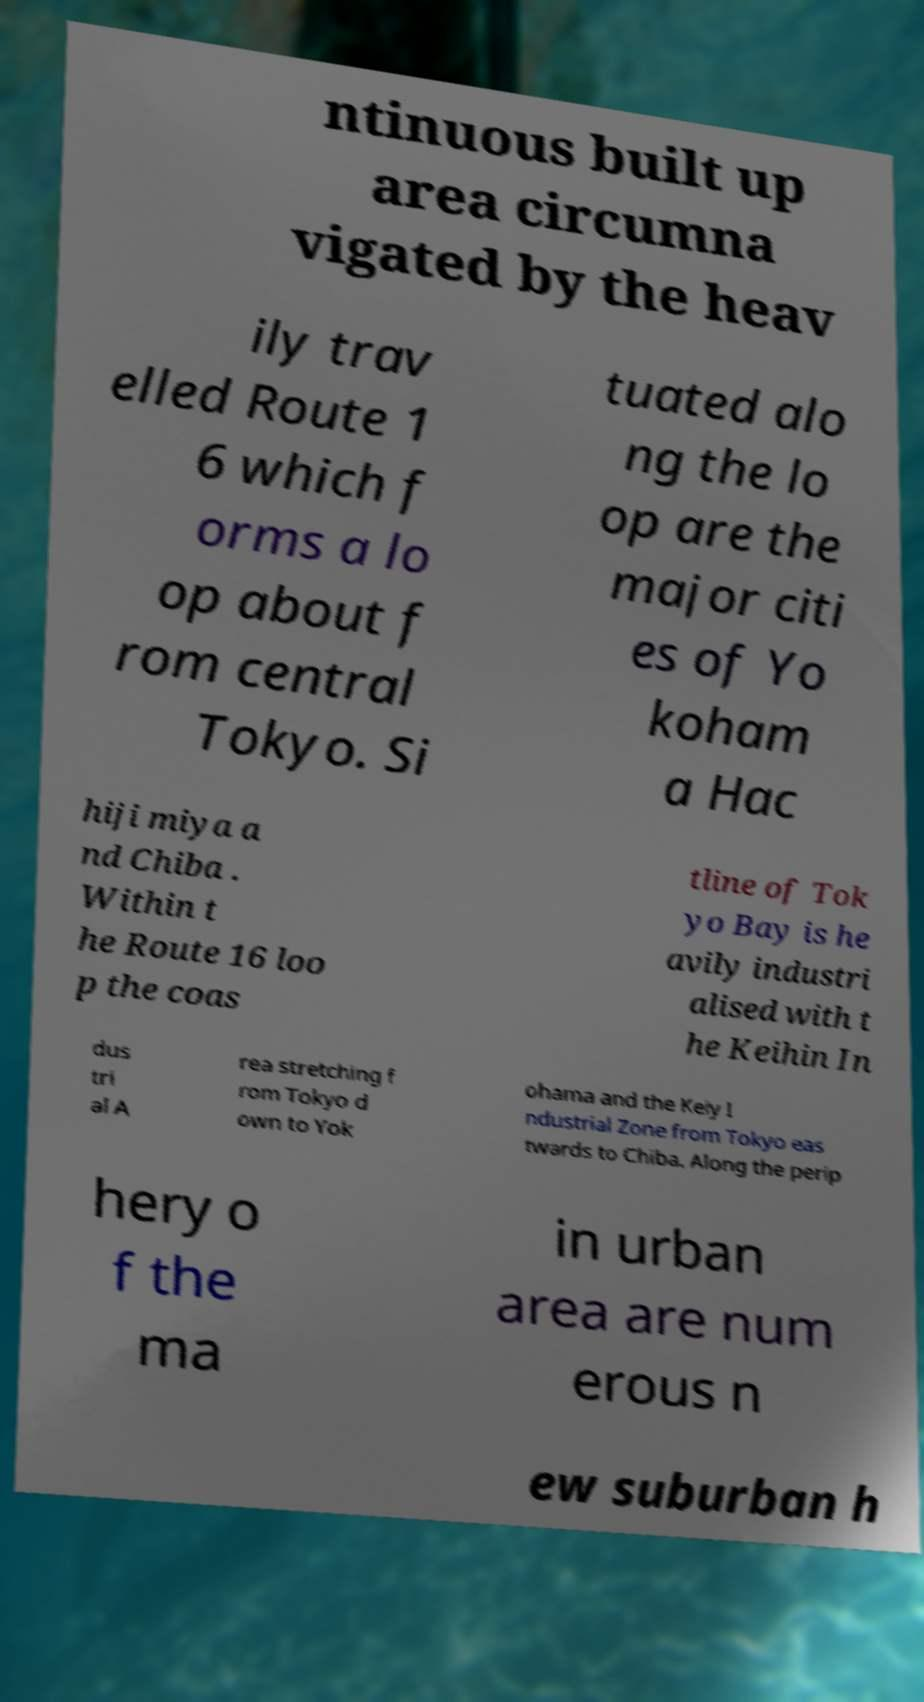Please identify and transcribe the text found in this image. ntinuous built up area circumna vigated by the heav ily trav elled Route 1 6 which f orms a lo op about f rom central Tokyo. Si tuated alo ng the lo op are the major citi es of Yo koham a Hac hiji miya a nd Chiba . Within t he Route 16 loo p the coas tline of Tok yo Bay is he avily industri alised with t he Keihin In dus tri al A rea stretching f rom Tokyo d own to Yok ohama and the Keiy I ndustrial Zone from Tokyo eas twards to Chiba. Along the perip hery o f the ma in urban area are num erous n ew suburban h 